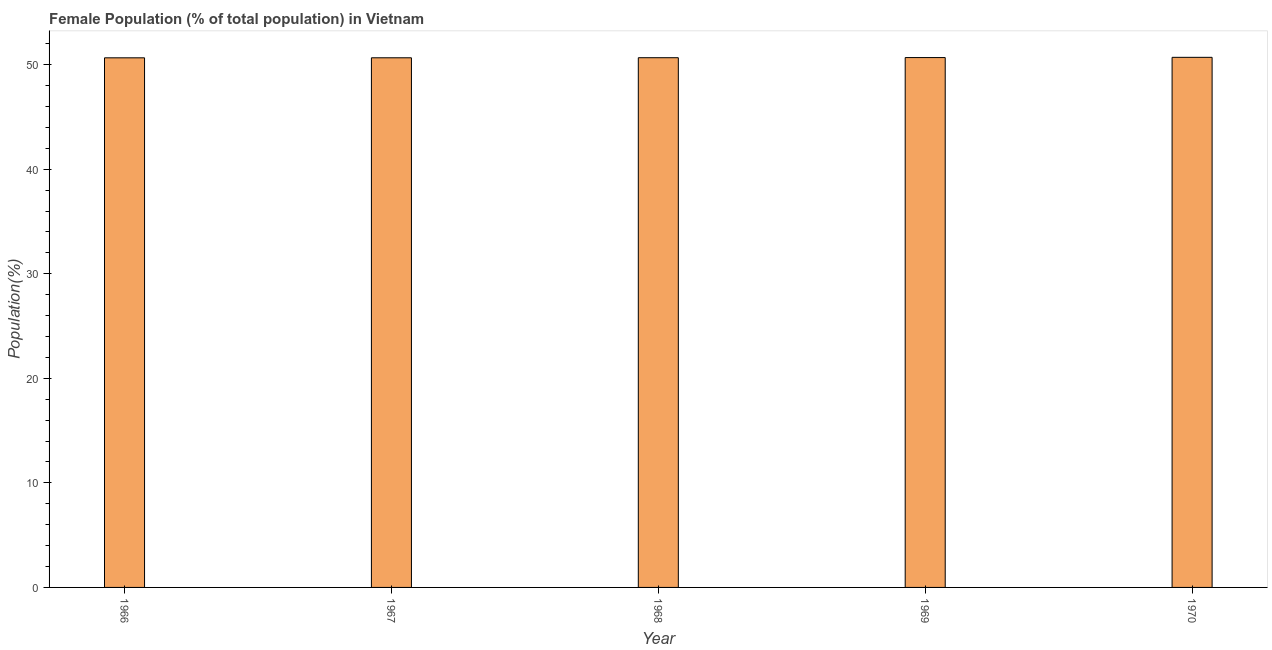Does the graph contain grids?
Offer a terse response. No. What is the title of the graph?
Your answer should be compact. Female Population (% of total population) in Vietnam. What is the label or title of the Y-axis?
Provide a succinct answer. Population(%). What is the female population in 1966?
Your answer should be compact. 50.66. Across all years, what is the maximum female population?
Provide a succinct answer. 50.71. Across all years, what is the minimum female population?
Keep it short and to the point. 50.66. In which year was the female population maximum?
Give a very brief answer. 1970. In which year was the female population minimum?
Offer a terse response. 1966. What is the sum of the female population?
Give a very brief answer. 253.39. What is the difference between the female population in 1967 and 1968?
Offer a terse response. -0.01. What is the average female population per year?
Your answer should be very brief. 50.68. What is the median female population?
Offer a very short reply. 50.67. In how many years, is the female population greater than 38 %?
Your answer should be compact. 5. Do a majority of the years between 1966 and 1969 (inclusive) have female population greater than 22 %?
Your answer should be compact. Yes. What is the ratio of the female population in 1968 to that in 1970?
Your response must be concise. 1. Is the female population in 1967 less than that in 1970?
Your answer should be compact. Yes. Is the difference between the female population in 1966 and 1967 greater than the difference between any two years?
Provide a succinct answer. No. What is the difference between the highest and the second highest female population?
Provide a short and direct response. 0.02. Is the sum of the female population in 1969 and 1970 greater than the maximum female population across all years?
Provide a short and direct response. Yes. What is the difference between the highest and the lowest female population?
Your response must be concise. 0.05. In how many years, is the female population greater than the average female population taken over all years?
Your response must be concise. 2. What is the difference between two consecutive major ticks on the Y-axis?
Give a very brief answer. 10. Are the values on the major ticks of Y-axis written in scientific E-notation?
Provide a succinct answer. No. What is the Population(%) in 1966?
Your answer should be very brief. 50.66. What is the Population(%) of 1967?
Provide a succinct answer. 50.66. What is the Population(%) in 1968?
Offer a very short reply. 50.67. What is the Population(%) in 1969?
Your answer should be compact. 50.69. What is the Population(%) in 1970?
Your response must be concise. 50.71. What is the difference between the Population(%) in 1966 and 1967?
Your answer should be very brief. -0. What is the difference between the Population(%) in 1966 and 1968?
Ensure brevity in your answer.  -0.01. What is the difference between the Population(%) in 1966 and 1969?
Keep it short and to the point. -0.03. What is the difference between the Population(%) in 1966 and 1970?
Provide a succinct answer. -0.05. What is the difference between the Population(%) in 1967 and 1968?
Your answer should be very brief. -0.01. What is the difference between the Population(%) in 1967 and 1969?
Your response must be concise. -0.02. What is the difference between the Population(%) in 1967 and 1970?
Give a very brief answer. -0.04. What is the difference between the Population(%) in 1968 and 1969?
Your answer should be compact. -0.01. What is the difference between the Population(%) in 1968 and 1970?
Provide a succinct answer. -0.04. What is the difference between the Population(%) in 1969 and 1970?
Make the answer very short. -0.02. What is the ratio of the Population(%) in 1966 to that in 1968?
Provide a short and direct response. 1. What is the ratio of the Population(%) in 1966 to that in 1969?
Offer a very short reply. 1. What is the ratio of the Population(%) in 1966 to that in 1970?
Offer a terse response. 1. What is the ratio of the Population(%) in 1967 to that in 1968?
Provide a short and direct response. 1. What is the ratio of the Population(%) in 1967 to that in 1970?
Offer a very short reply. 1. What is the ratio of the Population(%) in 1968 to that in 1969?
Offer a very short reply. 1. What is the ratio of the Population(%) in 1969 to that in 1970?
Your answer should be compact. 1. 